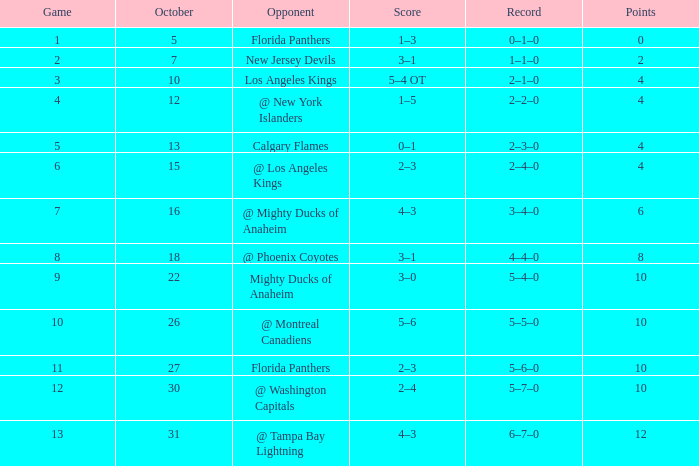What squad holds a score of 2? 3–1. 